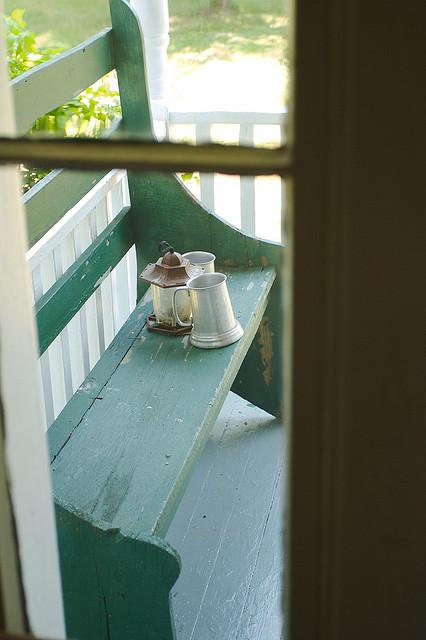What type of drinking vessels are on the bench?

Choices:
A) steins
B) teacups
C) lowball
D) espresso cups steins 